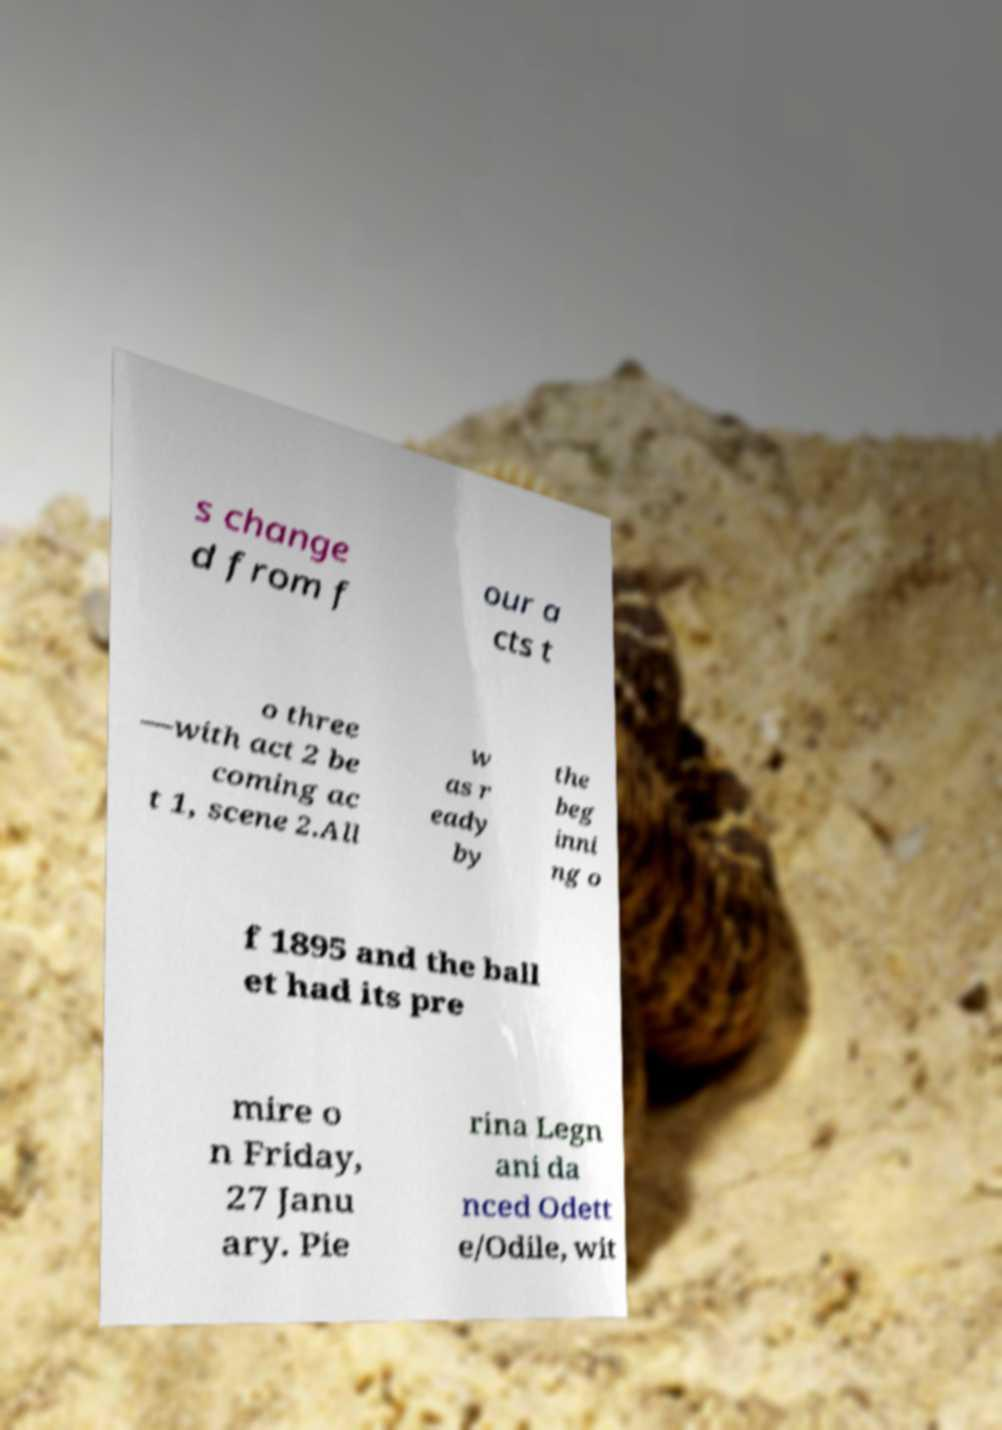Please identify and transcribe the text found in this image. s change d from f our a cts t o three —with act 2 be coming ac t 1, scene 2.All w as r eady by the beg inni ng o f 1895 and the ball et had its pre mire o n Friday, 27 Janu ary. Pie rina Legn ani da nced Odett e/Odile, wit 